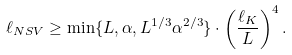<formula> <loc_0><loc_0><loc_500><loc_500>\ell _ { N S V } \geq \min \{ L , \alpha , L ^ { 1 / 3 } \alpha ^ { 2 / 3 } \} \cdot \left ( \frac { \ell _ { K } } { L } \right ) ^ { 4 } .</formula> 